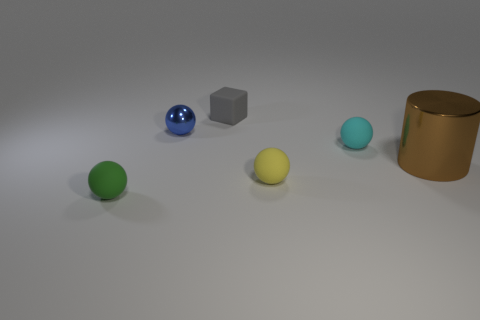Subtract all gray balls. Subtract all cyan blocks. How many balls are left? 4 Add 3 tiny matte things. How many objects exist? 9 Subtract all cylinders. How many objects are left? 5 Add 6 blue metallic spheres. How many blue metallic spheres exist? 7 Subtract 0 yellow cubes. How many objects are left? 6 Subtract all small purple matte objects. Subtract all tiny green matte spheres. How many objects are left? 5 Add 1 cyan matte balls. How many cyan matte balls are left? 2 